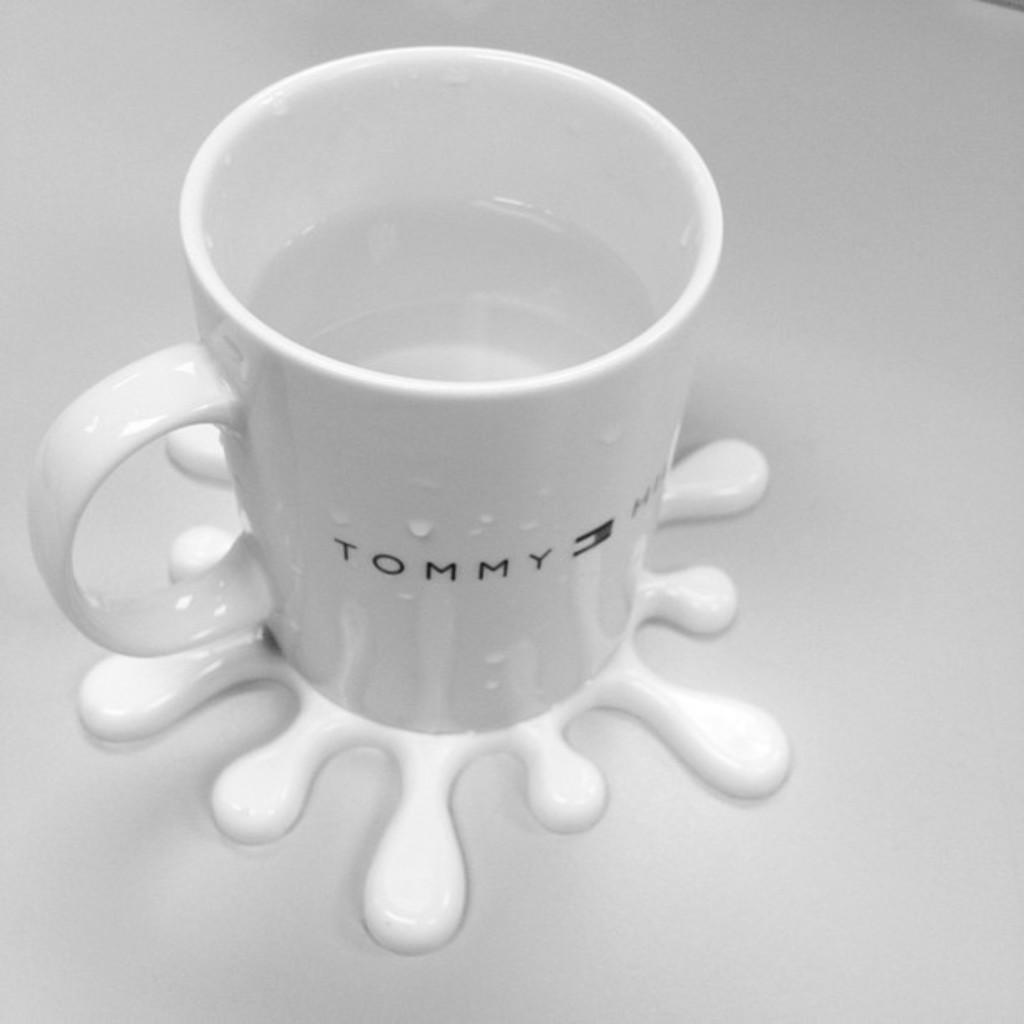What object is present in the image? There is a cup in the image. What color is the cup? The cup is white in color. What is inside the cup? There is water in the cup. What is the cup placed on? The cup is on a white colored surface. How does the girl express her anger towards the fuel in the image? There is no girl, anger, or fuel present in the image; it only features a white cup with water on a white surface. 